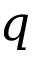Convert formula to latex. <formula><loc_0><loc_0><loc_500><loc_500>q</formula> 